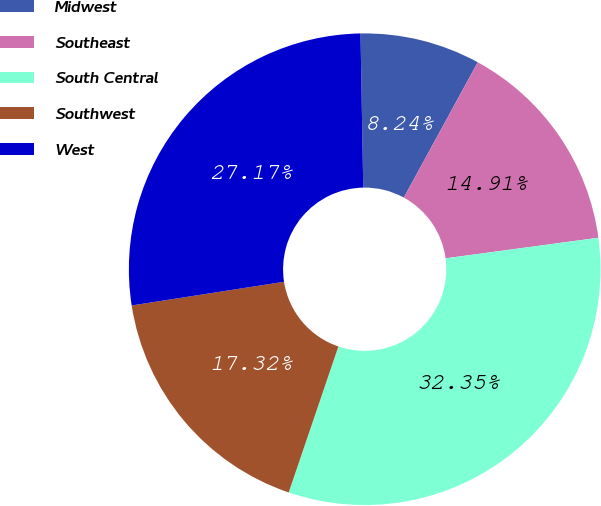Convert chart. <chart><loc_0><loc_0><loc_500><loc_500><pie_chart><fcel>Midwest<fcel>Southeast<fcel>South Central<fcel>Southwest<fcel>West<nl><fcel>8.24%<fcel>14.91%<fcel>32.35%<fcel>17.32%<fcel>27.17%<nl></chart> 